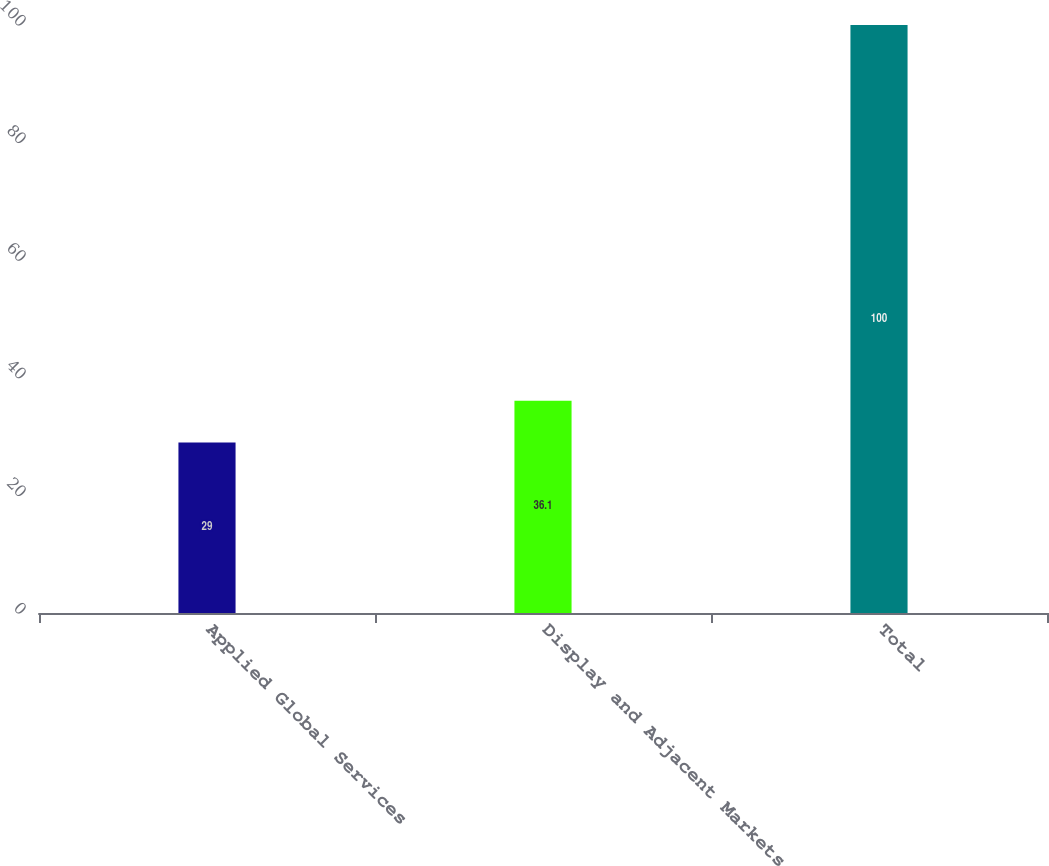Convert chart. <chart><loc_0><loc_0><loc_500><loc_500><bar_chart><fcel>Applied Global Services<fcel>Display and Adjacent Markets<fcel>Total<nl><fcel>29<fcel>36.1<fcel>100<nl></chart> 